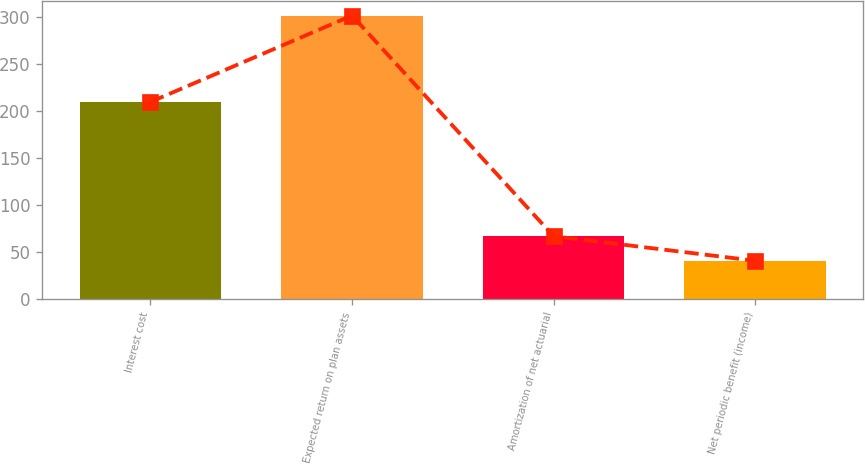Convert chart. <chart><loc_0><loc_0><loc_500><loc_500><bar_chart><fcel>Interest cost<fcel>Expected return on plan assets<fcel>Amortization of net actuarial<fcel>Net periodic benefit (income)<nl><fcel>210<fcel>302<fcel>67.1<fcel>41<nl></chart> 